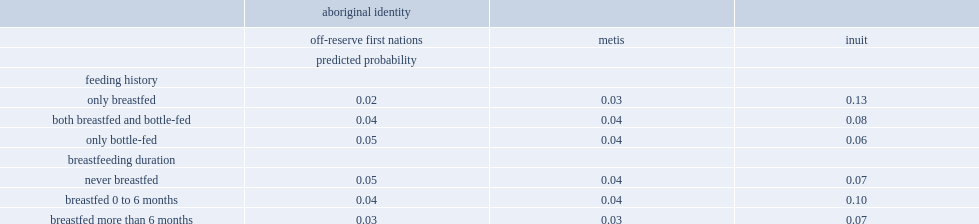After several factors were controlled for in a logistic regression model, which feeding history of first nations children living off reserve were significantly less likely to have chronic ear infections, who were only breastfed or children who were only bottle-fed? Only breastfed. Which breastfeeding duration of off-reserve first nations children were significantly less likely to have chronic ear infections, who were breastfed for more than six months or their counterparts who were not breastfed? Breastfed more than 6 months. 